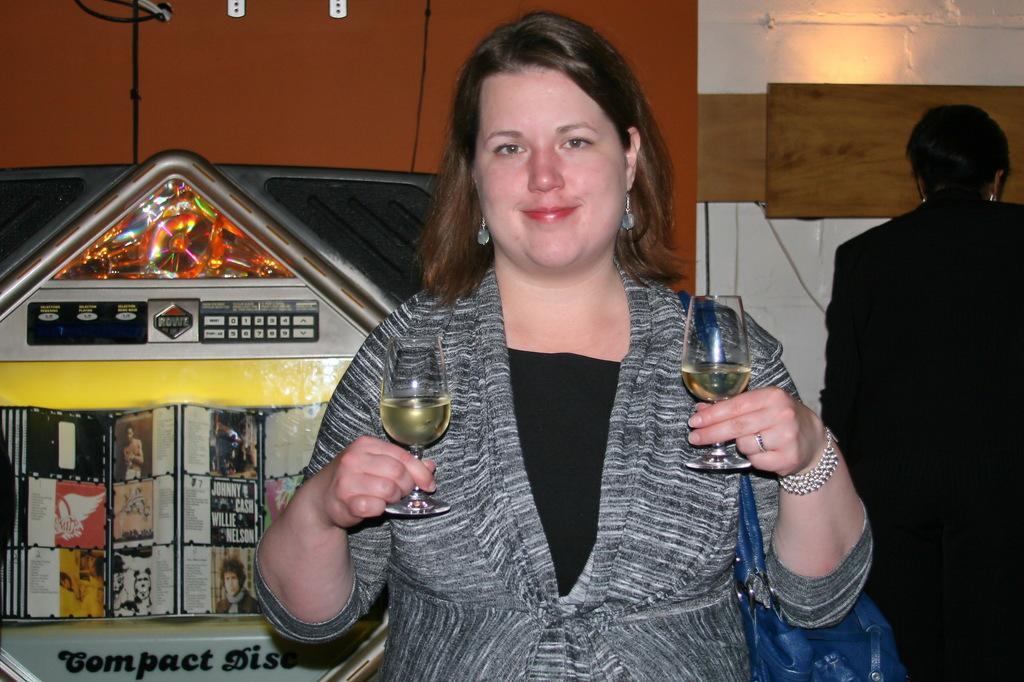Could you give a brief overview of what you see in this image? In this image i can see a in the right side there is a person wearing a black color shirt and there is a woman on the center she holding a glasses. and glasses contain a drink and she wearing a gray color dress ,on her right hand she wearing a band she is smiling. On the left hand on the corner there a text. 